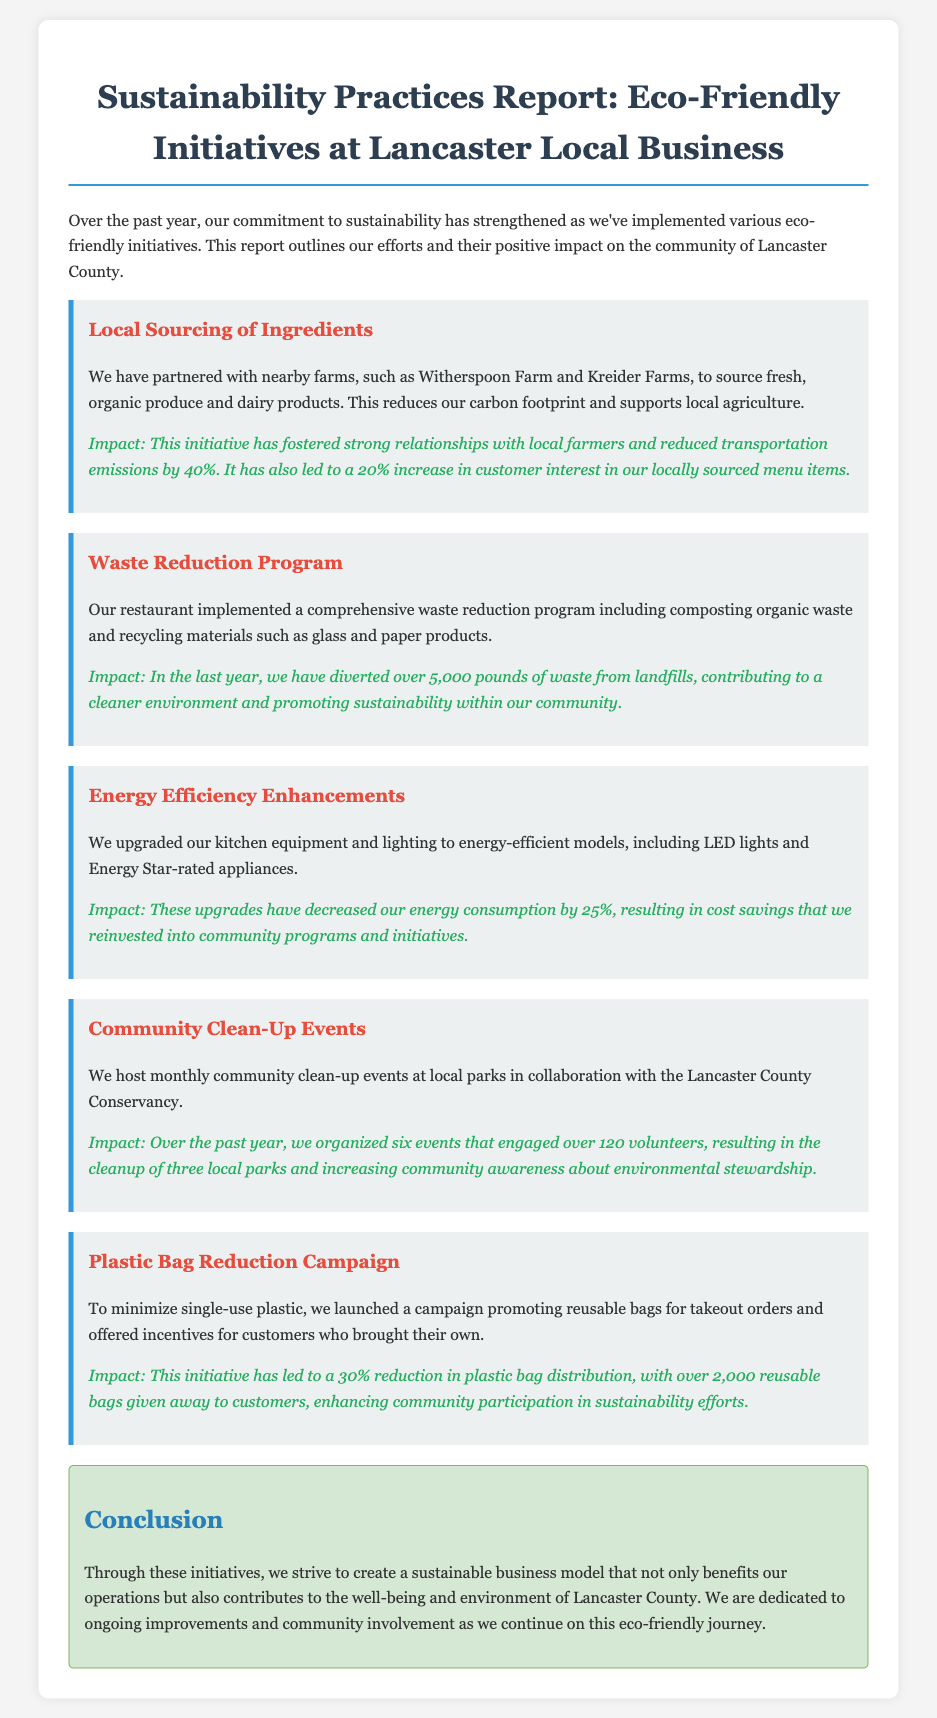What is the name of one farm partnered for local sourcing? The document mentions partnerships with "Witherspoon Farm" and "Kreider Farms" as part of the local sourcing initiative.
Answer: Witherspoon Farm How much have they reduced transportation emissions by? The report states a reduction of "40%" in transportation emissions due to the local sourcing initiative.
Answer: 40% What is the total amount of waste diverted from landfills? The report mentions that over "5,000 pounds" of waste were diverted from landfills through the waste reduction program.
Answer: 5,000 pounds By what percentage has energy consumption decreased? The document specifies a "25%" decrease in energy consumption resulting from energy efficiency enhancements.
Answer: 25% How many community clean-up events were organized? According to the report, they organized "six events" over the past year for community clean-up.
Answer: six What are the incentives offered for the plastic bag reduction campaign? The document mentions that "incentives for customers who brought their own" bags were part of the plastic bag reduction campaign.
Answer: incentives for customers who brought their own What is the main goal of the sustainability initiatives described? The document reflects a commitment to creating a sustainable business model that contributes to the "well-being and environment of Lancaster County."
Answer: well-being and environment of Lancaster County How many volunteers participated in community clean-up events? The report indicates that "over 120 volunteers" participated in the clean-up events organized by the business.
Answer: over 120 volunteers 